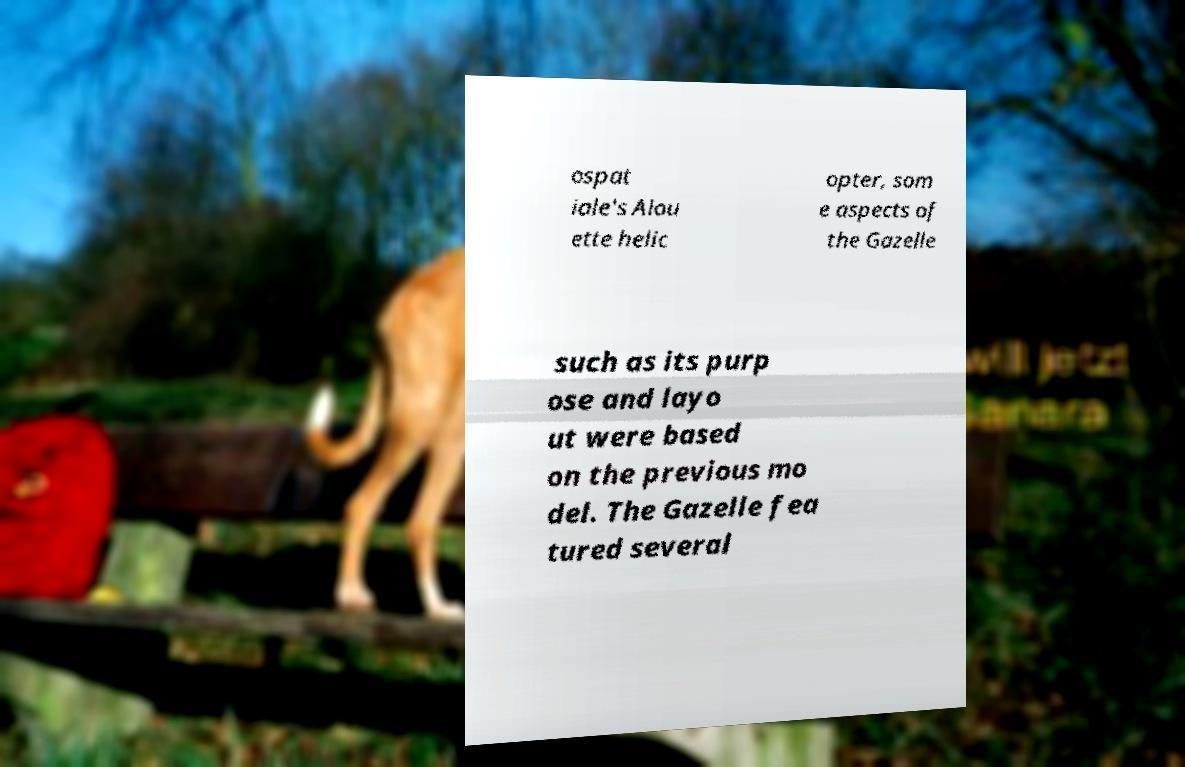Please read and relay the text visible in this image. What does it say? ospat iale's Alou ette helic opter, som e aspects of the Gazelle such as its purp ose and layo ut were based on the previous mo del. The Gazelle fea tured several 